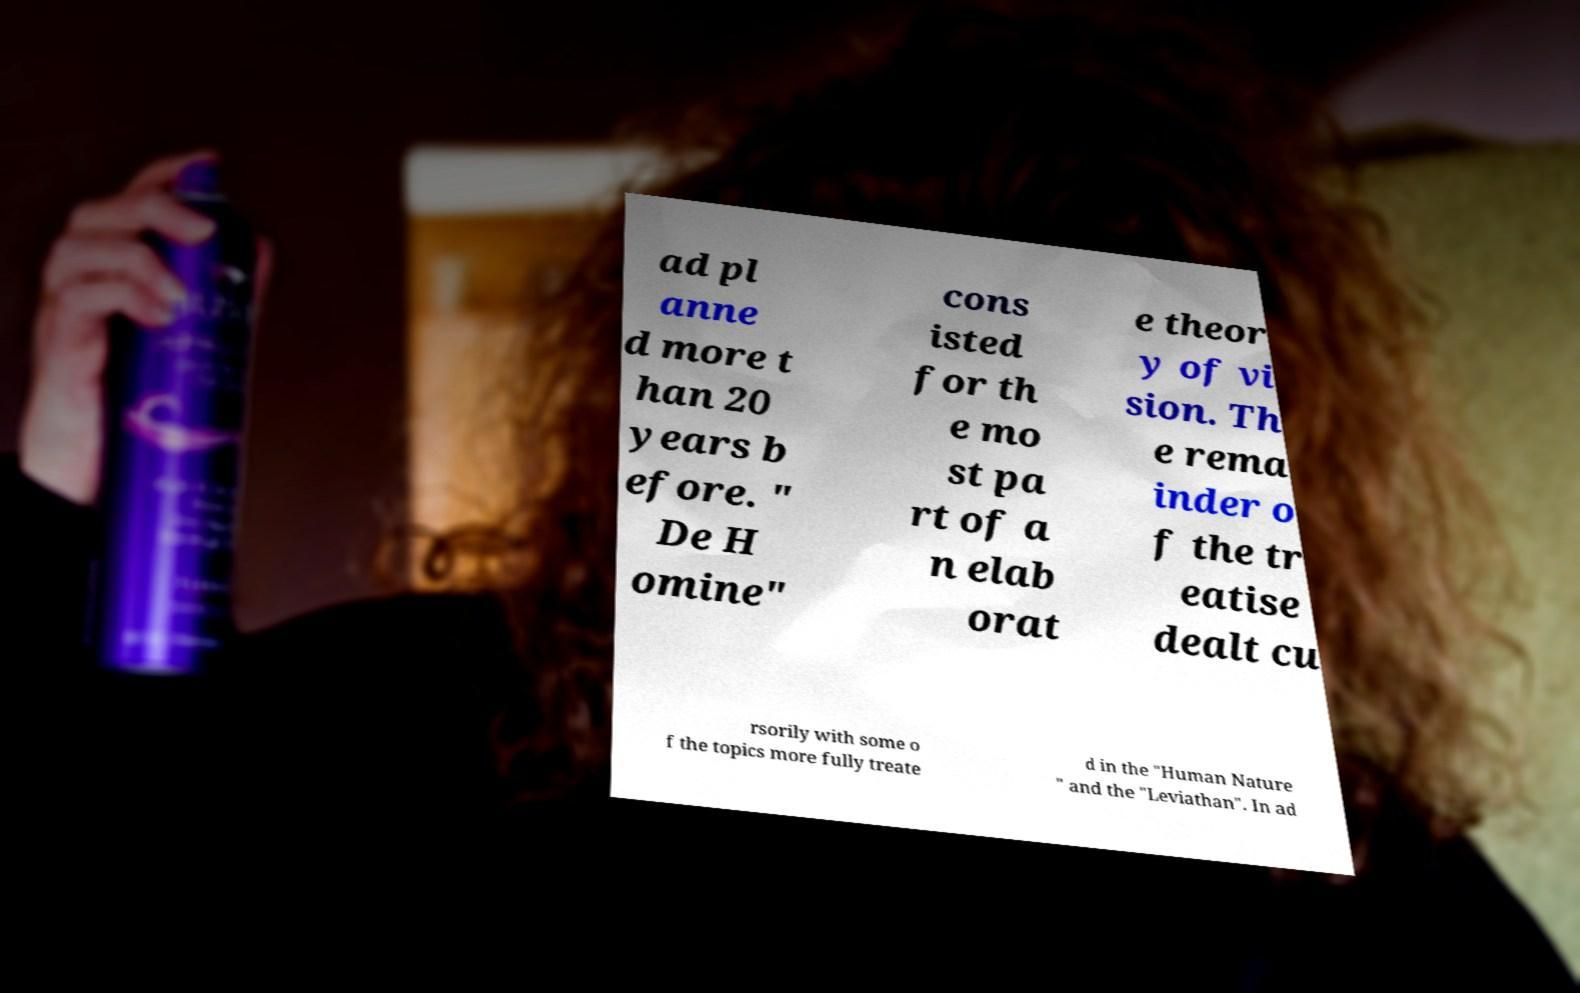Please read and relay the text visible in this image. What does it say? ad pl anne d more t han 20 years b efore. " De H omine" cons isted for th e mo st pa rt of a n elab orat e theor y of vi sion. Th e rema inder o f the tr eatise dealt cu rsorily with some o f the topics more fully treate d in the "Human Nature " and the "Leviathan". In ad 